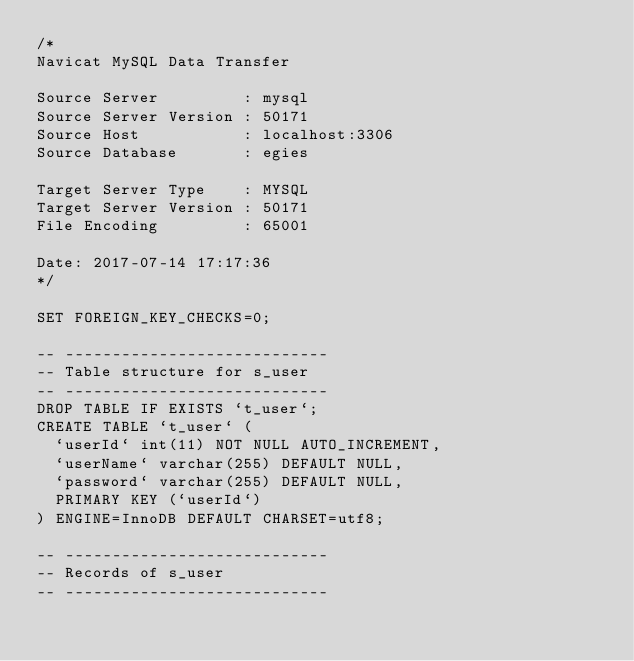Convert code to text. <code><loc_0><loc_0><loc_500><loc_500><_SQL_>/*
Navicat MySQL Data Transfer

Source Server         : mysql
Source Server Version : 50171
Source Host           : localhost:3306
Source Database       : egies

Target Server Type    : MYSQL
Target Server Version : 50171
File Encoding         : 65001

Date: 2017-07-14 17:17:36
*/

SET FOREIGN_KEY_CHECKS=0;

-- ----------------------------
-- Table structure for s_user
-- ----------------------------
DROP TABLE IF EXISTS `t_user`;
CREATE TABLE `t_user` (
  `userId` int(11) NOT NULL AUTO_INCREMENT,
  `userName` varchar(255) DEFAULT NULL,
  `password` varchar(255) DEFAULT NULL,
  PRIMARY KEY (`userId`)
) ENGINE=InnoDB DEFAULT CHARSET=utf8;

-- ----------------------------
-- Records of s_user
-- ----------------------------
</code> 